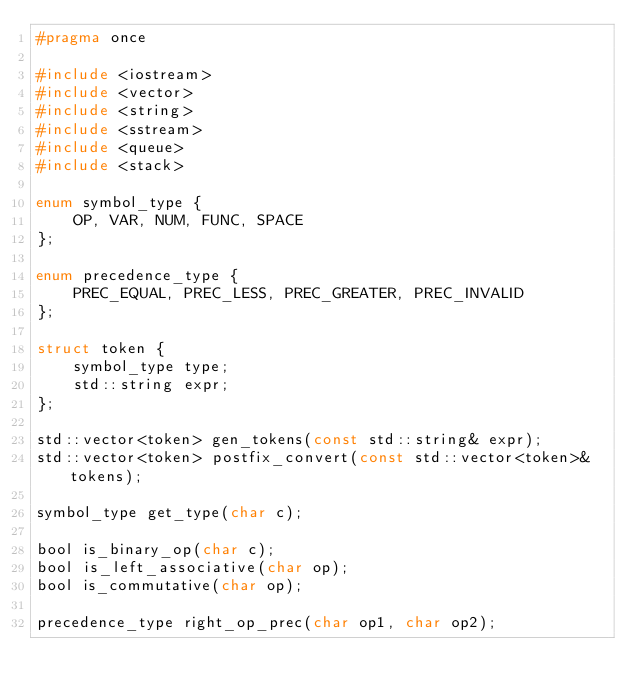Convert code to text. <code><loc_0><loc_0><loc_500><loc_500><_C_>#pragma once

#include <iostream>
#include <vector>
#include <string>
#include <sstream>
#include <queue>
#include <stack>

enum symbol_type {
    OP, VAR, NUM, FUNC, SPACE
};

enum precedence_type {
    PREC_EQUAL, PREC_LESS, PREC_GREATER, PREC_INVALID
};

struct token {
    symbol_type type;
    std::string expr;
};

std::vector<token> gen_tokens(const std::string& expr);
std::vector<token> postfix_convert(const std::vector<token>& tokens);

symbol_type get_type(char c);

bool is_binary_op(char c);
bool is_left_associative(char op);
bool is_commutative(char op);

precedence_type right_op_prec(char op1, char op2);</code> 